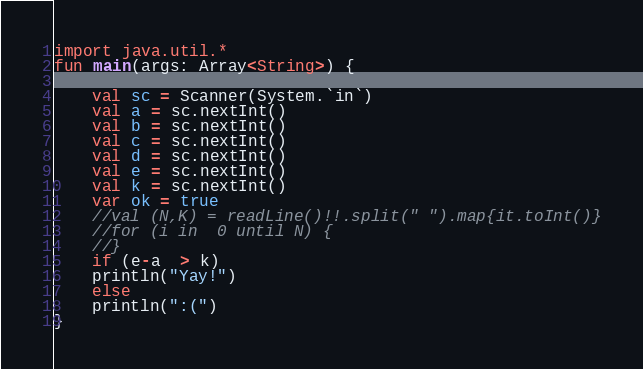Convert code to text. <code><loc_0><loc_0><loc_500><loc_500><_Kotlin_>import java.util.*
fun main(args: Array<String>) {

    val sc = Scanner(System.`in`)
    val a = sc.nextInt()
    val b = sc.nextInt()
    val c = sc.nextInt()
    val d = sc.nextInt()
    val e = sc.nextInt()
    val k = sc.nextInt()
    var ok = true
    //val (N,K) = readLine()!!.split(" ").map{it.toInt()}
    //for (i in  0 until N) {
    //}
    if (e-a  > k)
    println("Yay!")
    else
    println(":(")
}
</code> 